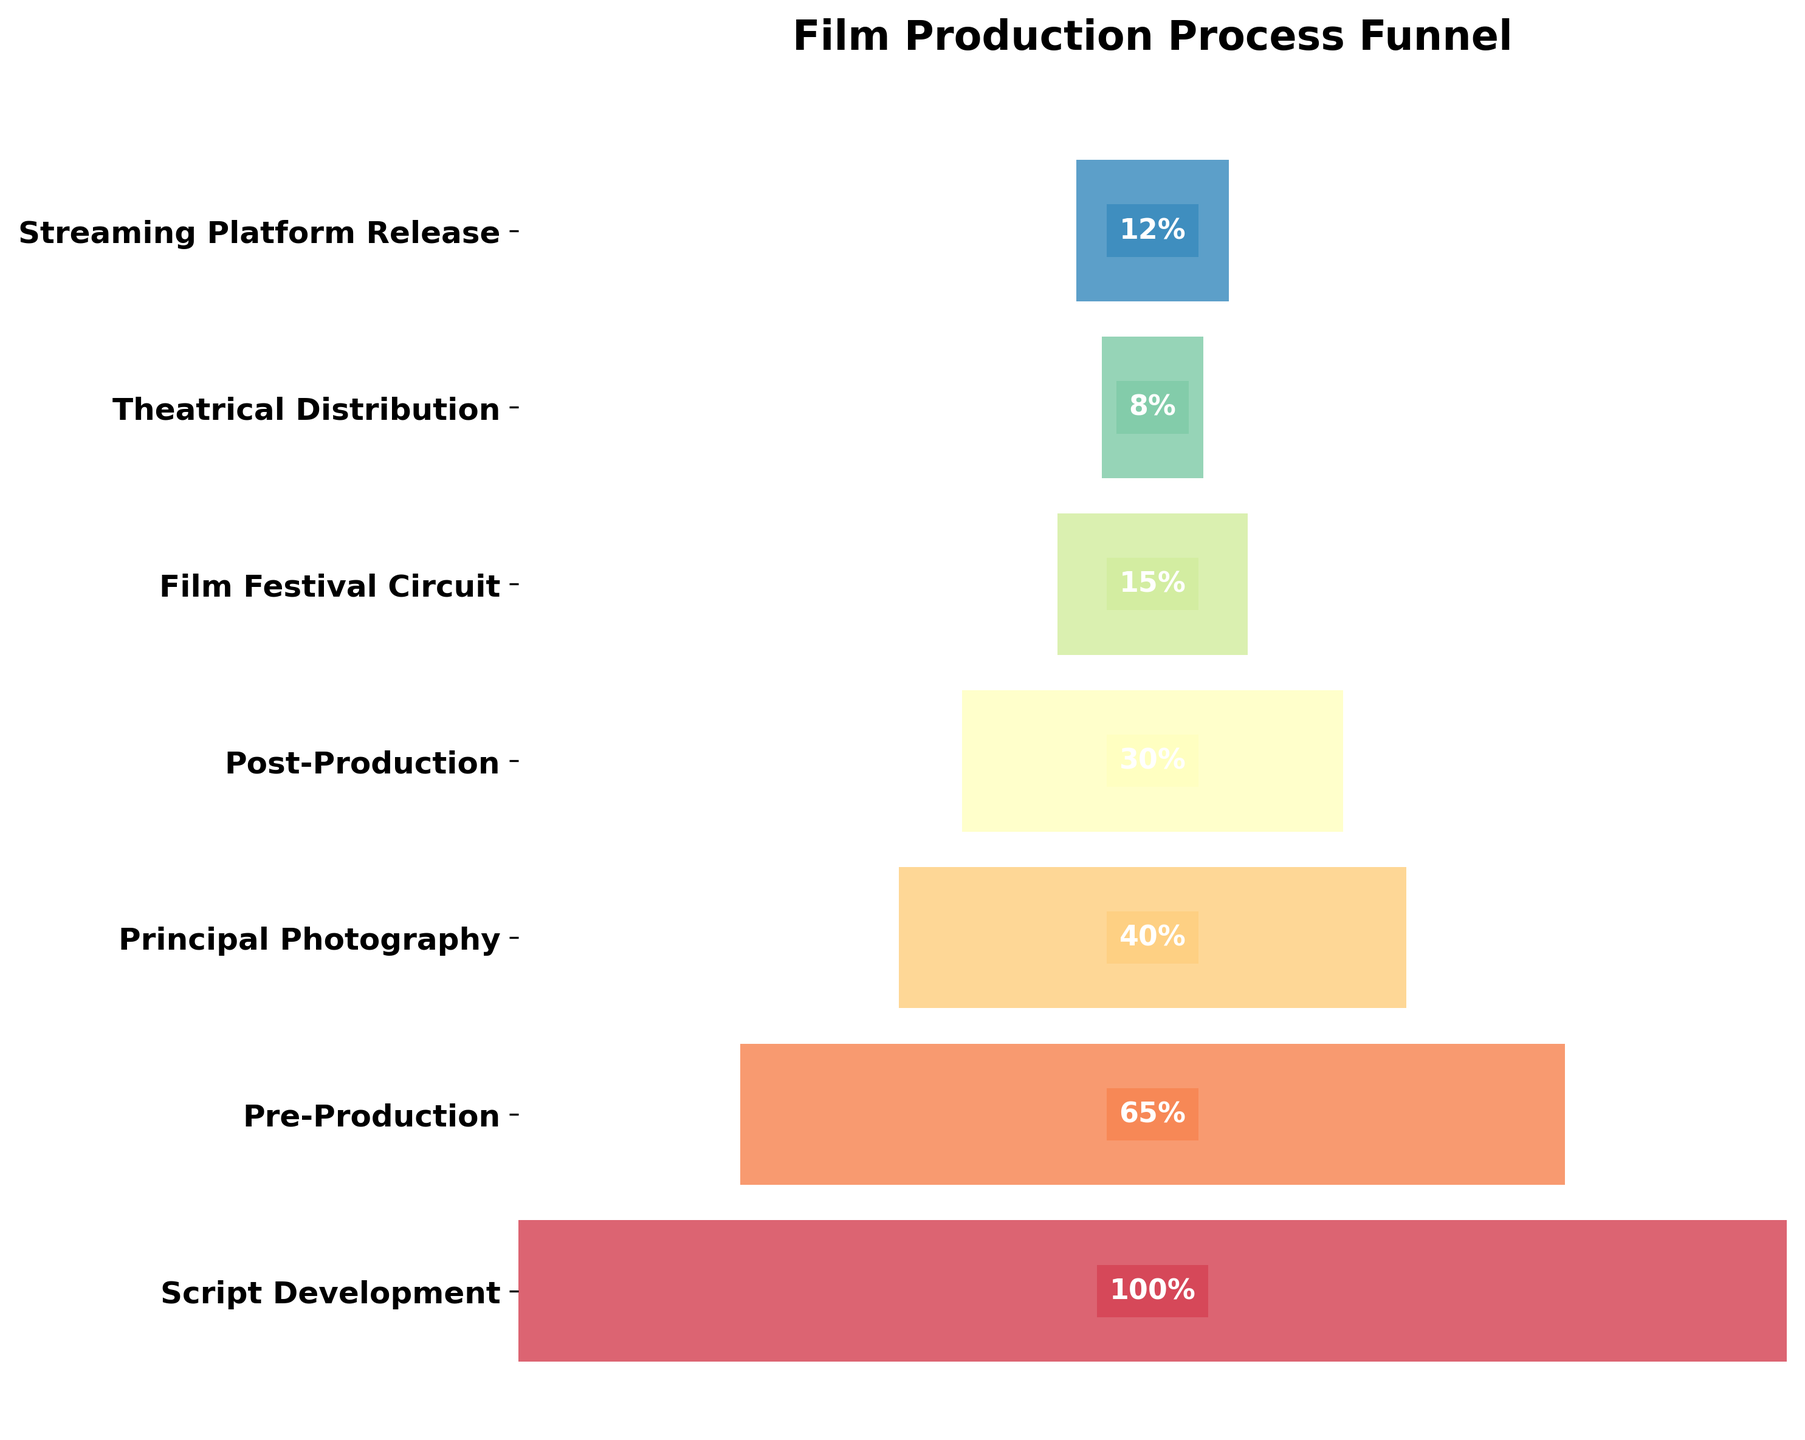what is the title of the chart? The title of the chart is prominently displayed at the top and describes the overall topic being visualized. In this case, it should be clear from the chart's display.
Answer: Film Production Process Funnel Which stage has the highest percentage of projects completing it? The chart uses percentage labels inside each bar to show what percentage of projects complete each stage. By looking for the largest percentage label, we see that "Script Development" has 100%.
Answer: Script Development How many stages are represented in the chart? Count the number of distinct horizontal bars or labels on the y-axis. Each bar or label represents a different stage.
Answer: 7 What percentage of projects reach the Post-Production stage? Find the bar labeled "Post-Production" and read the percentage shown within that bar.
Answer: 30% Which stage has the lowest completion percentage? Identify the bar with the smallest percentage label to find the stage with the lowest percentage of projects completing it. According to the chart, "Theatrical Distribution" is the stage with the lowest completion percentage.
Answer: Theatrical Distribution Is the percentage of projects completing the Film Festival Circuit higher or lower than those reaching Principal Photography? Compare the percentages inside the bars labeled "Film Festival Circuit" and "Principal Photography." The Film Festival Circuit has 15%, and Principal Photography has 40%.
Answer: Lower Calculate the average completion percentage for the stages from Principal Photography to Streaming Platform Release. Add the completion percentages of Principal Photography (40%), Post-Production (30%), Film Festival Circuit (15%), Theatrical Distribution (8%), and Streaming Platform Release (12%), and then divide by the number of stages (5). This gives (40 + 30 + 15 + 8 + 12)/5 = 21%.
Answer: 21% Which stage sees less than half of the projects completing it? Identify the stages that have a percentage below 50% by looking at the percentage labels inside the bars. From the chart: Principal Photography (40%), Post-Production (30%), Film Festival Circuit (15%), Theatrical Distribution (8%), and Streaming Platform Release (12%) all meet this criterion.
Answer: Principal Photography, Post-Production, Film Festival Circuit, Theatrical Distribution, Streaming Platform Release Compare the change in completion percentage from Pre-Production to Principal Photography. Subtract the percentage of Principal Photography from the percentage of Pre-Production (65% - 40% = 25%). This represents a 25% decrease.
Answer: 25% decrease Does any stage have a higher completion percentage in Theatrical Distribution compared to Streaming Platform Release? Compare the percentages next to "Theatrical Distribution" and "Streaming Platform Release." Streaming Platform Release (12%) exceeds Theatrical Distribution (8%).
Answer: No, Streaming Platform Release is higher 